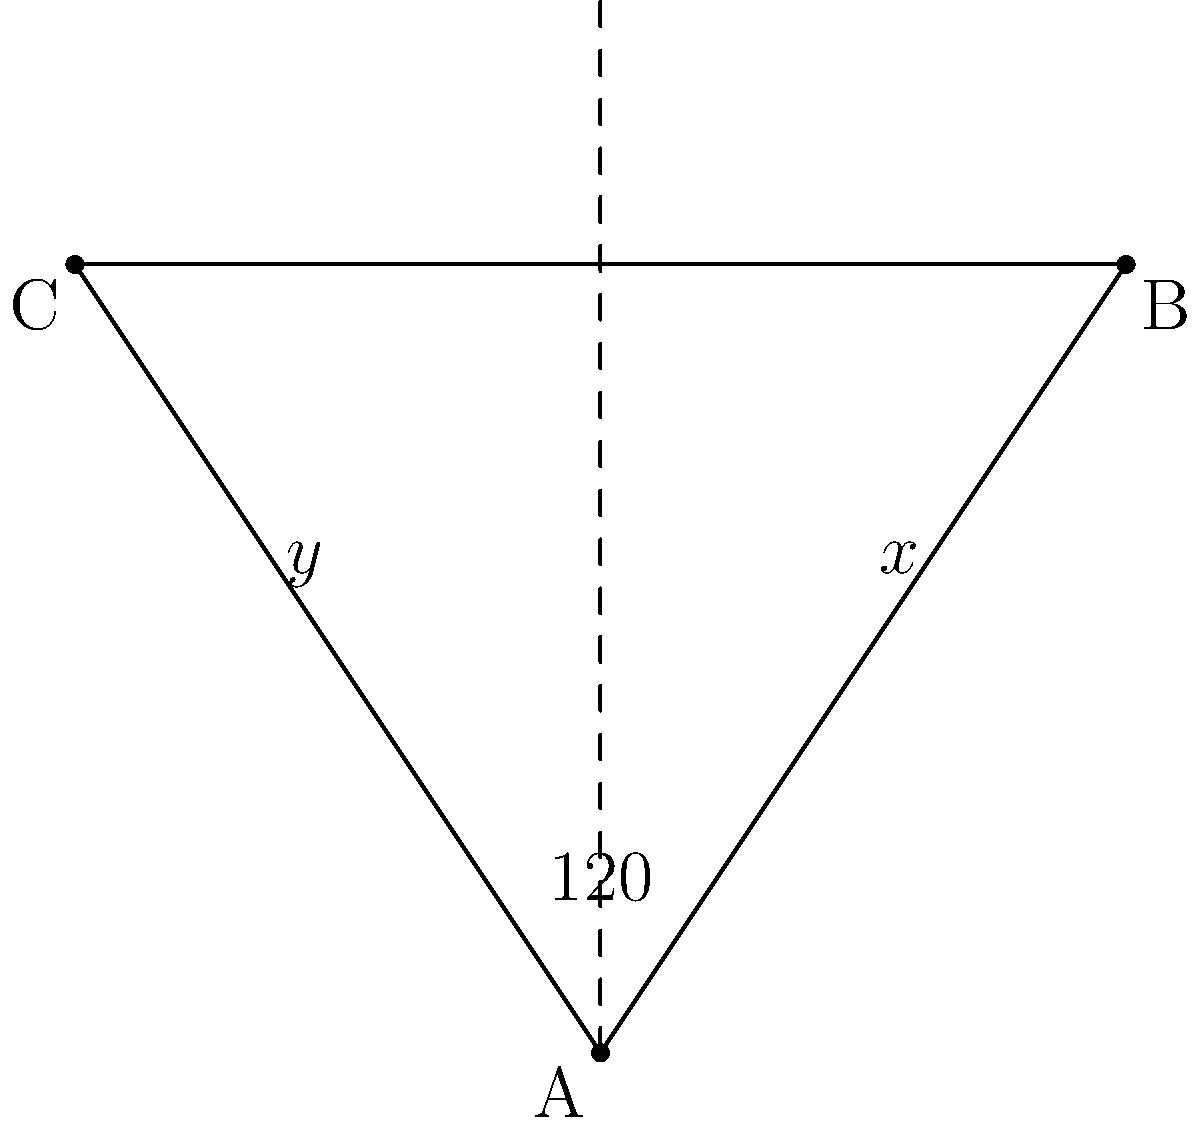In a study of blood vessel branching patterns, you observe a Y-shaped junction where two smaller vessels branch off from a larger one. The angle between the two smaller vessels is 120°. If the angle between one of the smaller vessels and the continuation of the larger vessel is $x°$, and the angle between the other smaller vessel and the continuation of the larger vessel is $y°$, what is the value of $x + y$? Let's approach this step-by-step:

1) In any point where lines meet, the sum of the angles around that point is always 360°.

2) In this Y-shaped junction, we have three angles:
   - The angle between the two smaller vessels (given as 120°)
   - The angle $x°$
   - The angle $y°$

3) These three angles should sum to 360°:

   $120° + x° + y° = 360°$

4) We're asked to find $x + y$. Let's isolate this in our equation:

   $x° + y° = 360° - 120°$

5) Simplify:

   $x° + y° = 240°$

Therefore, the sum of $x$ and $y$ is 240°.
Answer: 240° 